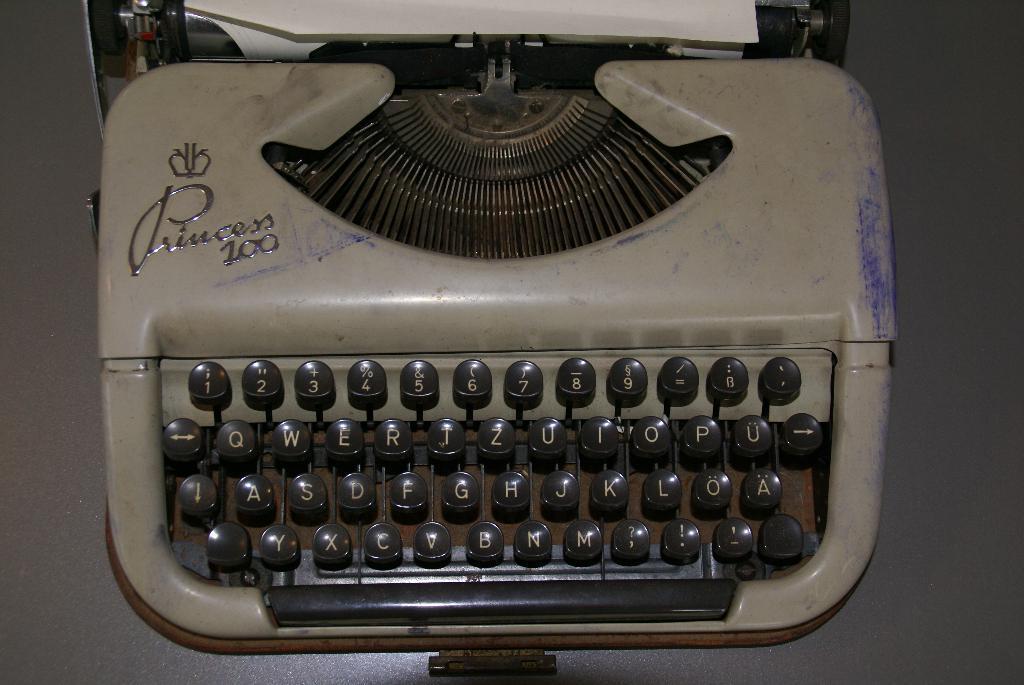Can you describe this image briefly? In this image we can see a typewriter and at the top of the image we can see a paper and there is a surface which looks like table. 